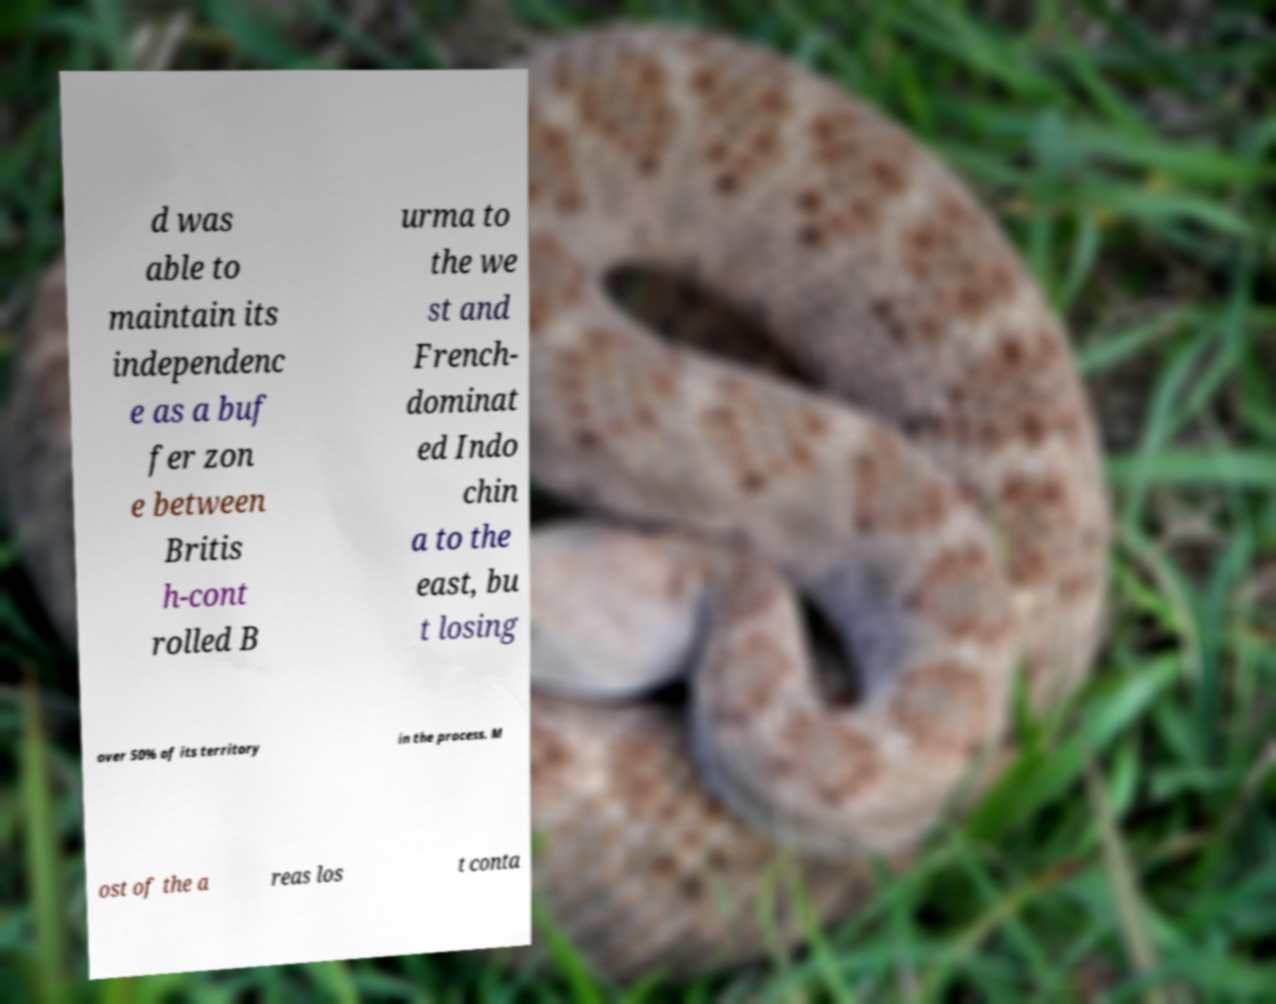I need the written content from this picture converted into text. Can you do that? d was able to maintain its independenc e as a buf fer zon e between Britis h-cont rolled B urma to the we st and French- dominat ed Indo chin a to the east, bu t losing over 50% of its territory in the process. M ost of the a reas los t conta 